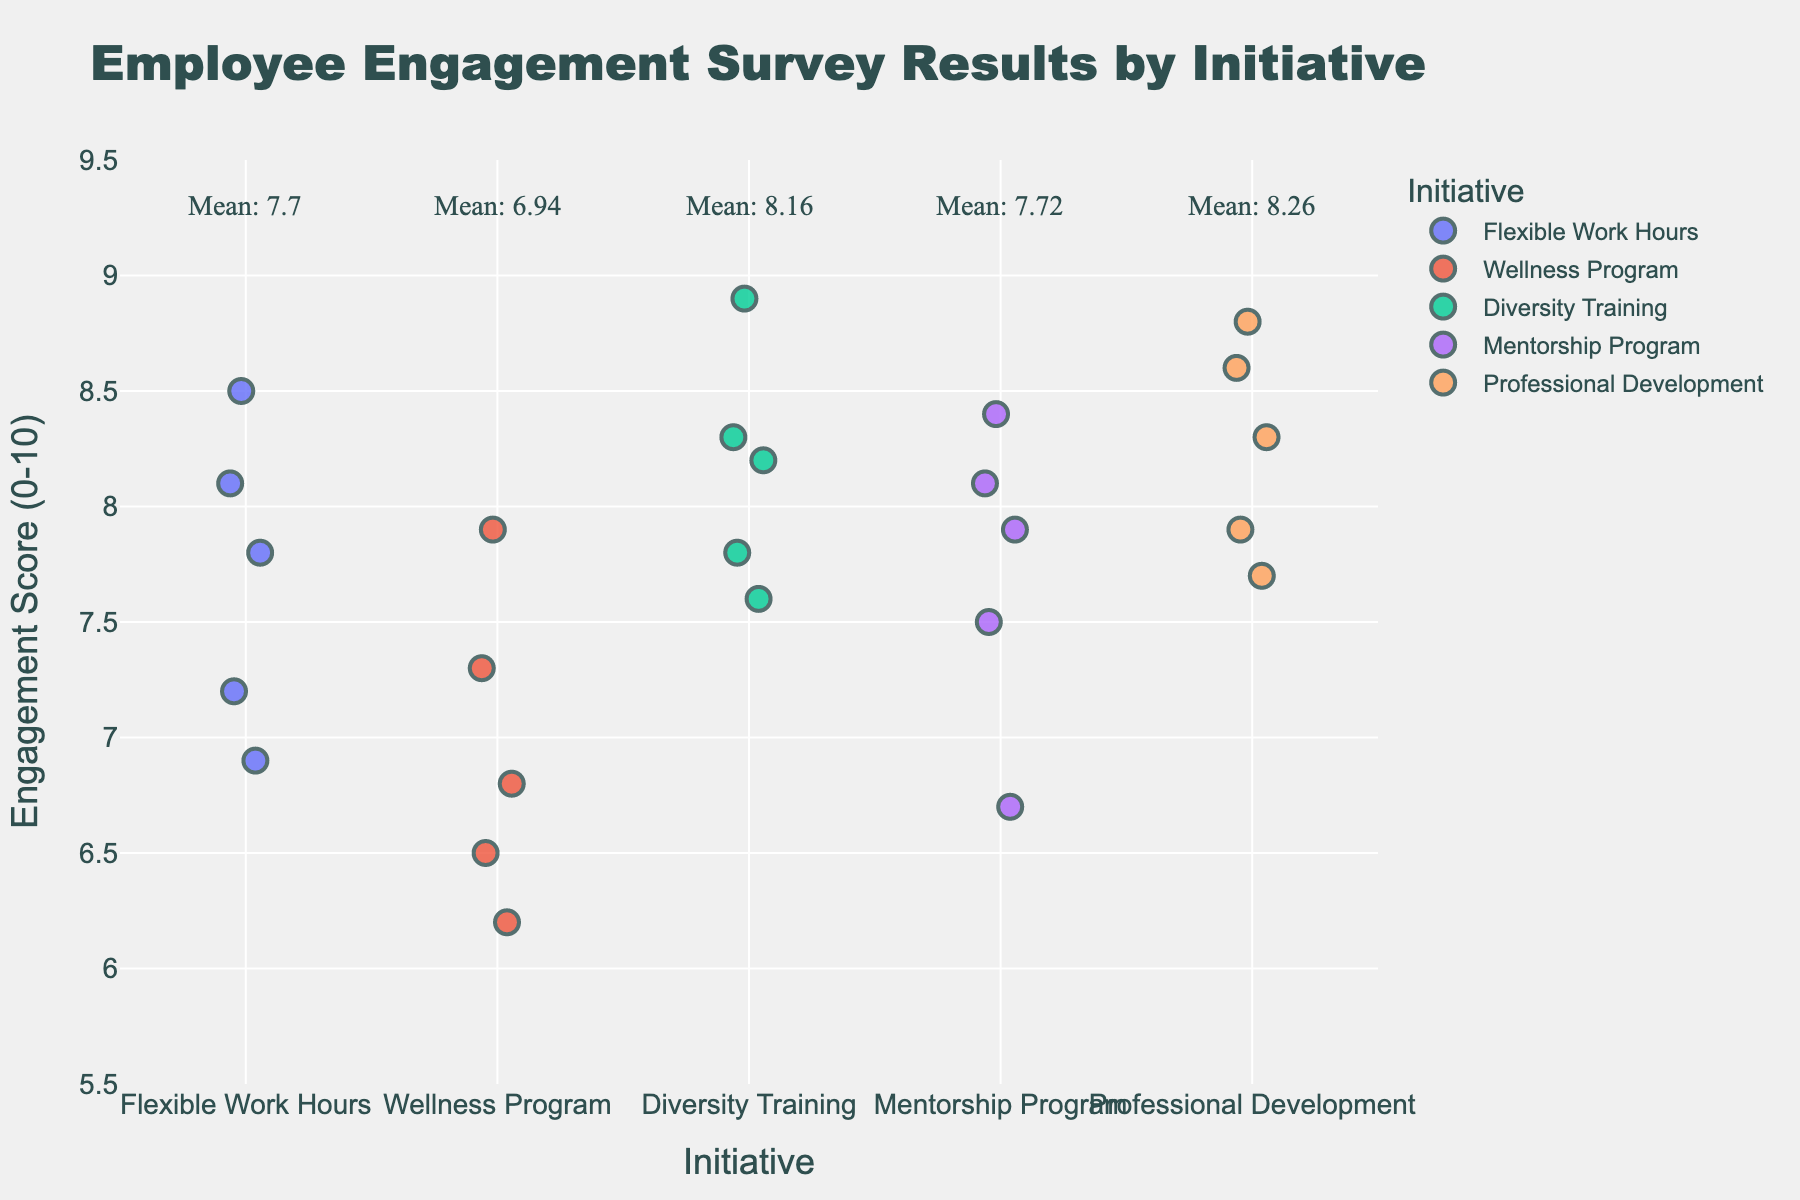What is the title of the figure? The title is located at the top of the figure, prominently displayed in larger font than other text elements. Its purpose is to summarize the content of the plot.
Answer: Employee Engagement Survey Results by Initiative How many initiatives are included in this figure? By counting the unique initiatives shown on the x-axis, we determine how many distinct categories are represented.
Answer: 5 What is the range of the Engagement Scores on the y-axis? By looking at the scale of the y-axis, we can see the minimum and maximum limits set for the Engagement Scores.
Answer: 5.5 to 9.5 Which initiative has the highest mean engagement score? The mean engagement score for each initiative is annotated near the top of the plot. Identify the initiative with the highest value.
Answer: Professional Development What's the mean engagement score for the Flexible Work Hours initiative? The mean score for each initiative is annotated near the top of the respective category. Locate the annotation for Flexible Work Hours.
Answer: 7.7 Which initiative has the most variability in engagement scores? Variability can be assessed by observing the spread of the data points within each initiative. The wider the spread, the higher the variability.
Answer: Wellness Program How many data points are there for the Wellness Program initiative? Count the number of individual points displayed within the Wellness Program category on the x-axis.
Answer: 5 What's the difference between the highest and lowest engagement scores for Diversity Training? Identify the highest and lowest data points for Diversity Training, then subtract the lowest score from the highest.
Answer: 2.1 Which initiative appears to have the most consistently high engagement scores? Consistency in high scores would be indicated by a tight clustering of data points near the upper limit of the y-axis.
Answer: Professional Development How does the mean engagement score for Mentorship Program compare to that for Diversity Training? Compare the annotated mean engagement scores for Mentorship Program and Diversity Training to see which is higher.
Answer: Mentorship Program has a lower mean than Diversity Training 